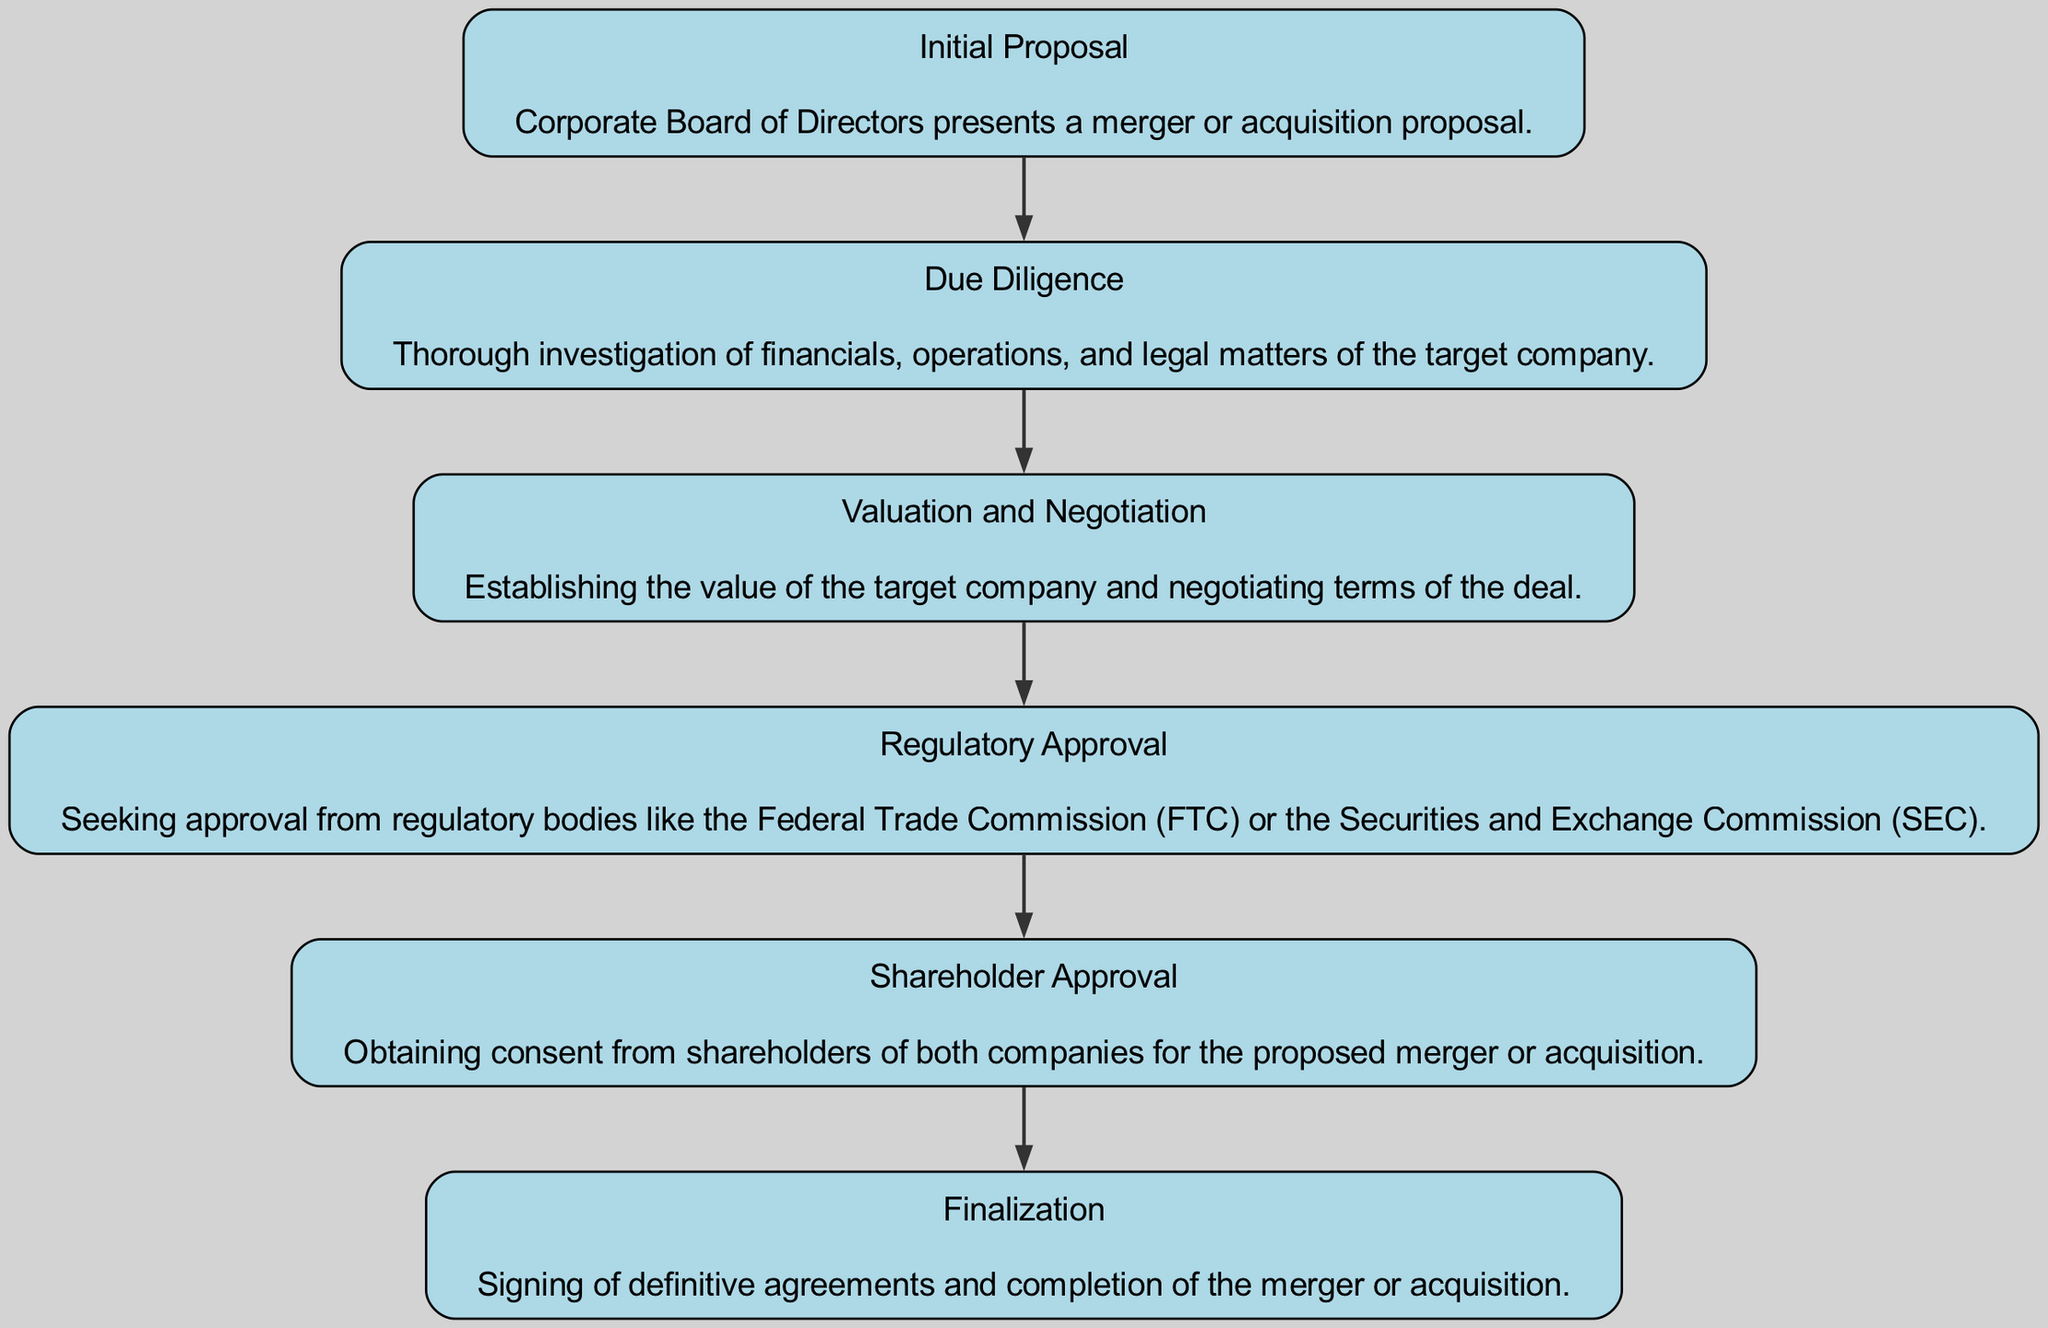What is the first stage in the merger and acquisition process? The first node in the diagram corresponds to the "Initial Proposal" stage, which is listed at the top of the flow chart.
Answer: Initial Proposal How many stages are there in total? By counting the nodes presented in the diagram, there are six stages illustrating the entire process from start to finish.
Answer: Six What follows the Due Diligence stage? The edge connecting the "Due Diligence" node to the next node leads to "Valuation and Negotiation," indicating that this is the subsequent stage in the flow.
Answer: Valuation and Negotiation Which stage requires approval from regulatory bodies? The "Regulatory Approval" stage explicitly mentions the necessity for approval from regulatory entities like the FTC or SEC, making it clear that this is the focus of that stage.
Answer: Regulatory Approval What two stages require approval from stakeholders? By analyzing the edges leading to both the "Regulatory Approval" and "Shareholder Approval" nodes, one can determine that both stages involve gaining necessary approvals pertaining to governance and compliance.
Answer: Regulatory Approval and Shareholder Approval What is the final stage in the corporate merger and acquisition process? As visualized at the bottom of the flow chart, the last stage is "Finalization," which completes the merger or acquisition after all previous steps have been fulfilled.
Answer: Finalization What describes the focus of the Due Diligence stage? The description associated with the "Due Diligence" stage provides clarity that it involves a thorough investigation of various aspects of the target company.
Answer: Investigation of financials, operations, and legal matters Which stage comes immediately before Shareholder Approval? The flow of edges shows that "Valuation and Negotiation" directly leads into "Regulatory Approval," which then connects to "Shareholder Approval." Hence, the stage before it is "Regulatory Approval."
Answer: Regulatory Approval What are the last actions that occur in the final stage? The "Finalization" stage description states that it involves the signing of definitive agreements and the completion of the merger or acquisition, indicating the actions taken here.
Answer: Signing of definitive agreements and completion of the merger or acquisition 